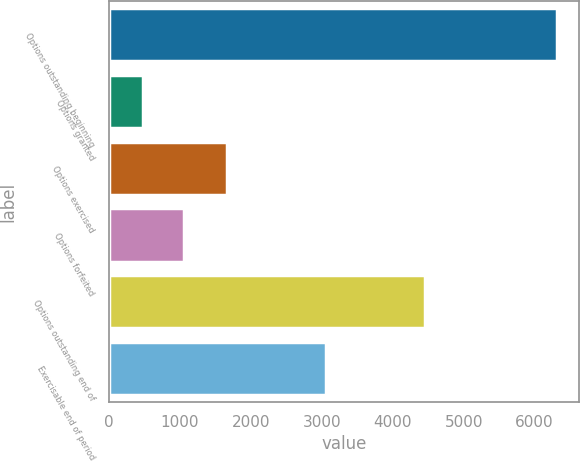Convert chart. <chart><loc_0><loc_0><loc_500><loc_500><bar_chart><fcel>Options outstanding beginning<fcel>Options granted<fcel>Options exercised<fcel>Options forfeited<fcel>Options outstanding end of<fcel>Exercisable end of period<nl><fcel>6311<fcel>480<fcel>1666<fcel>1063.1<fcel>4460<fcel>3065<nl></chart> 